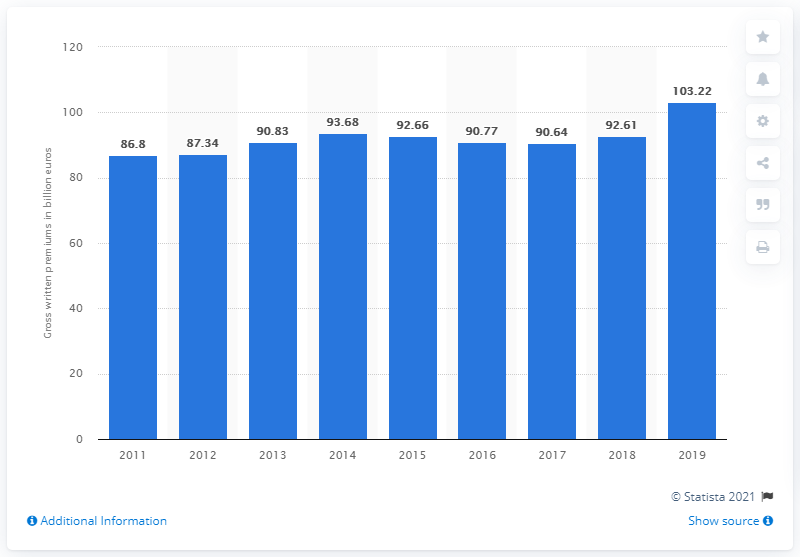Draw attention to some important aspects in this diagram. The value of gross written premiums in Germany in 2019 was 103.22. In 2011, the lowest value of life insurance written premiums was 87.34. 